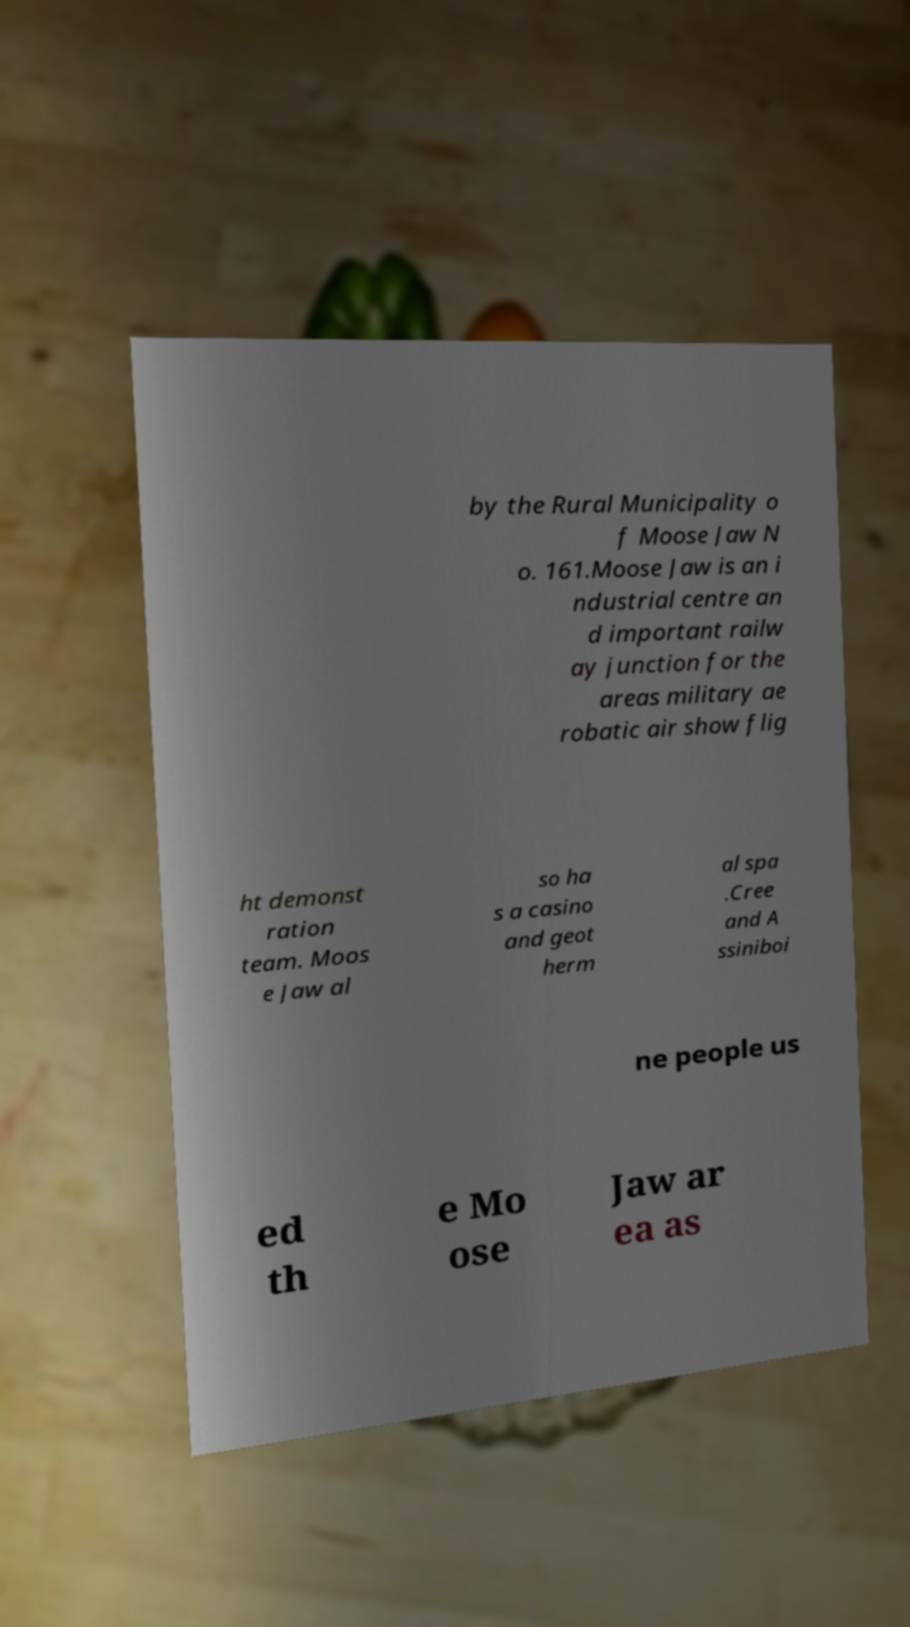Can you accurately transcribe the text from the provided image for me? by the Rural Municipality o f Moose Jaw N o. 161.Moose Jaw is an i ndustrial centre an d important railw ay junction for the areas military ae robatic air show flig ht demonst ration team. Moos e Jaw al so ha s a casino and geot herm al spa .Cree and A ssiniboi ne people us ed th e Mo ose Jaw ar ea as 